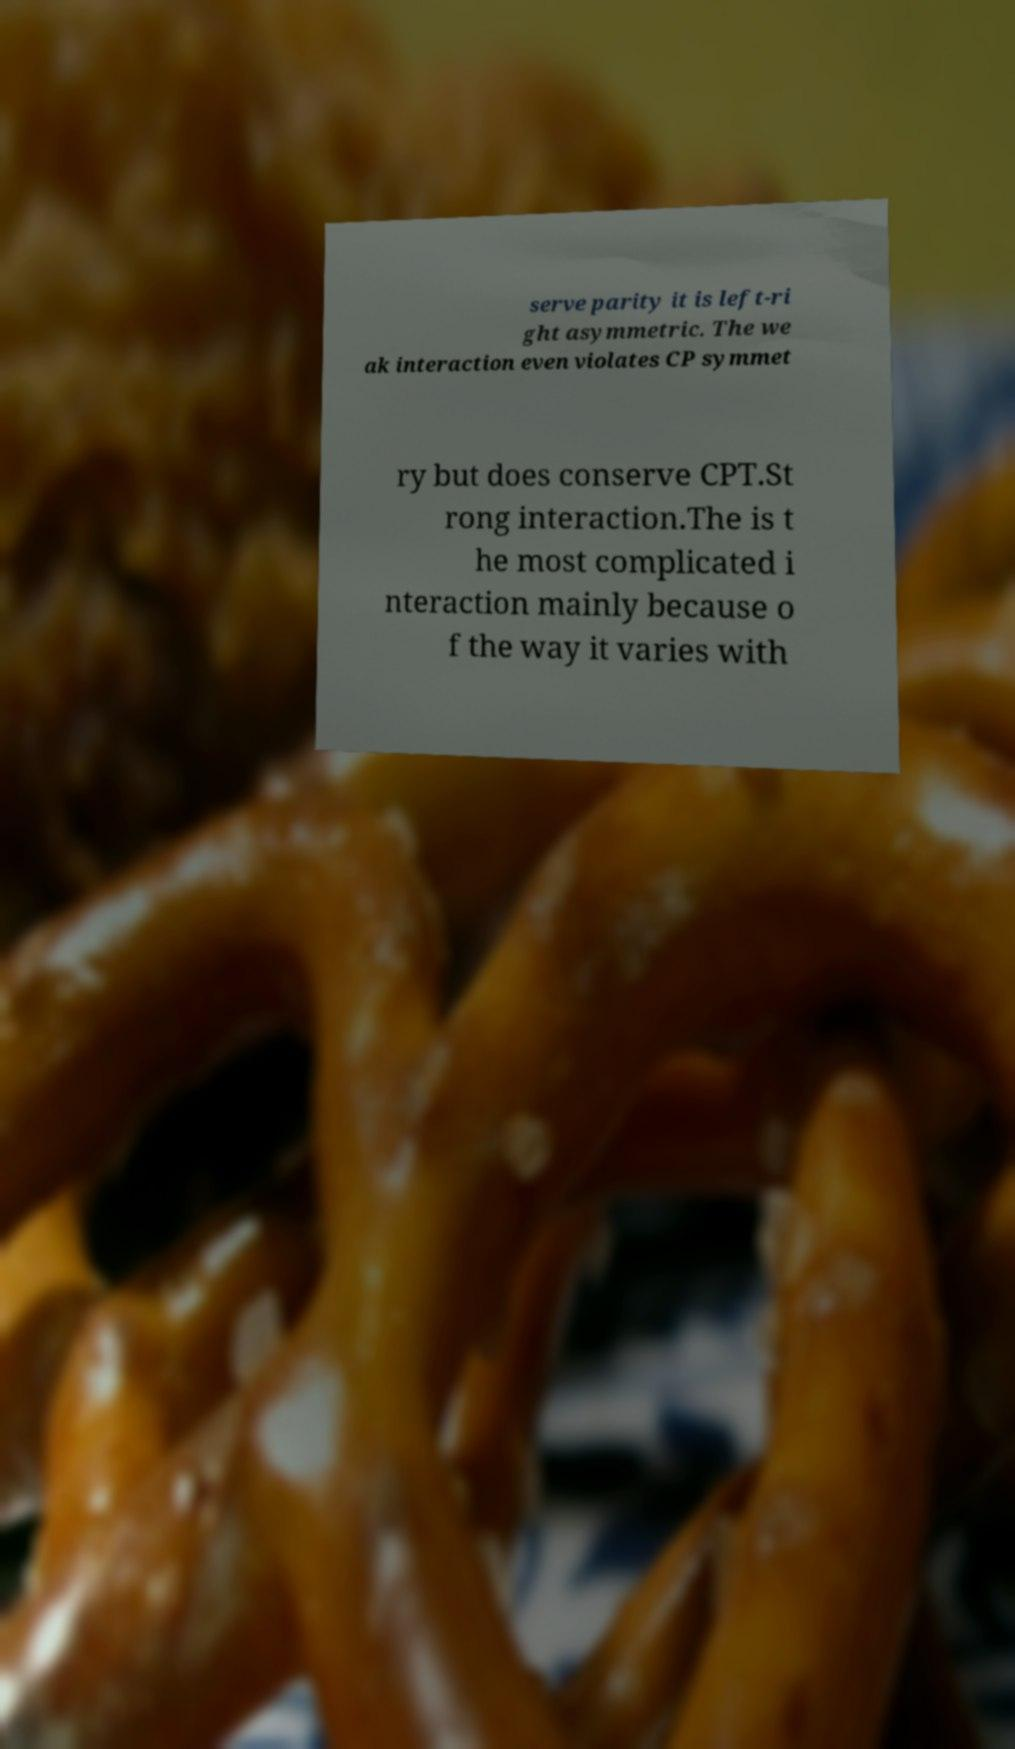Can you accurately transcribe the text from the provided image for me? serve parity it is left-ri ght asymmetric. The we ak interaction even violates CP symmet ry but does conserve CPT.St rong interaction.The is t he most complicated i nteraction mainly because o f the way it varies with 